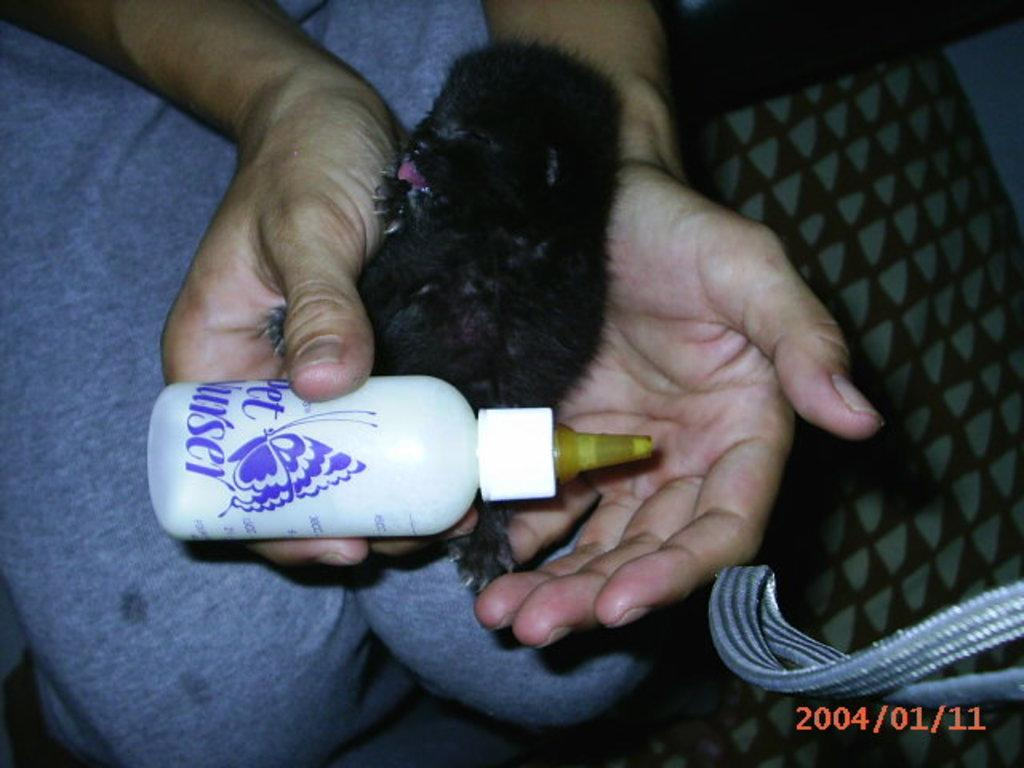What type of animal is in the image? There is a small black dog in the image. How is the dog being held in the image? The dog is being held by a person. What object is the person holding along with the dog? There is a milk bottle in the person's hands. What type of trail can be seen in the background of the image? There is no trail visible in the image; it only shows a small black dog being held by a person with a milk bottle in their hands. 